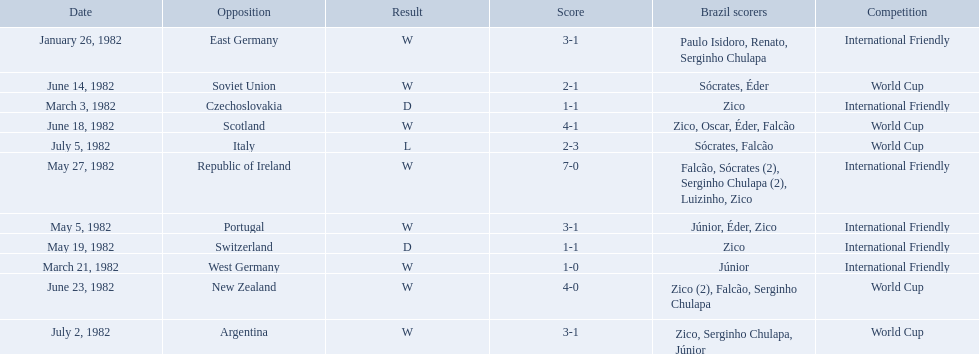Who did brazil play against Soviet Union. Who scored the most goals? Portugal. How many goals did brazil score against the soviet union? 2-1. How many goals did brazil score against portugal? 3-1. Did brazil score more goals against portugal or the soviet union? Portugal. 